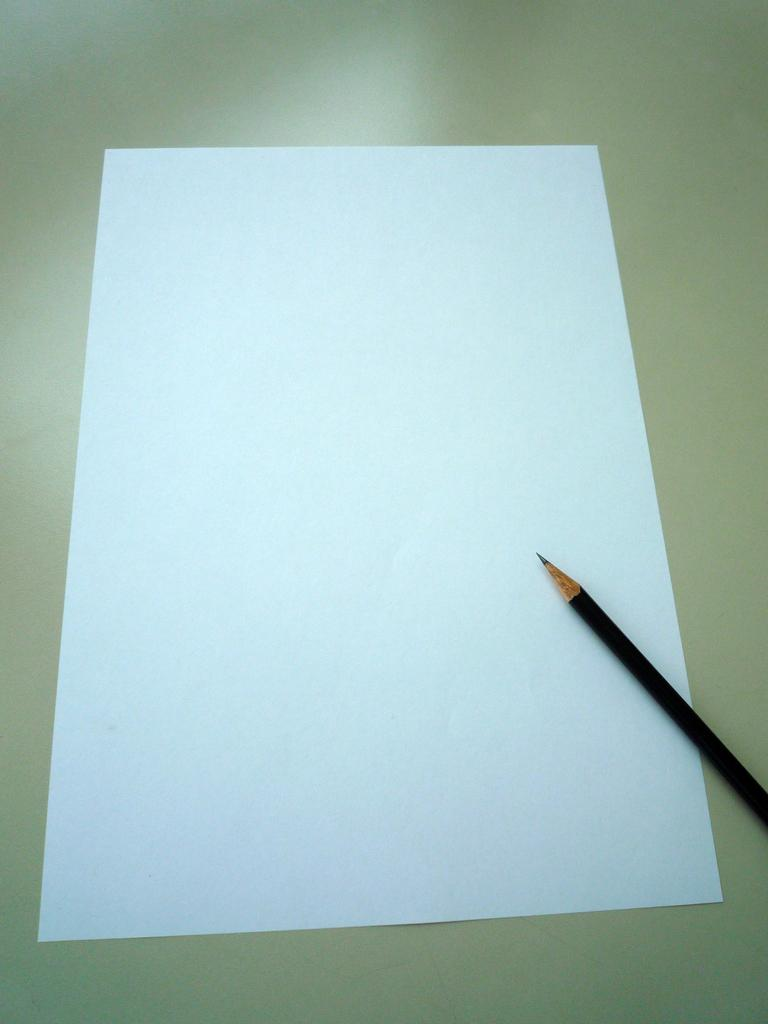What object can be seen in the image? There is a pencil in the image. What is the pencil placed on? The pencil is on a white paper. Where is the hose located in the image? There is no hose present in the image. What type of badge is visible on the pencil? There is no badge present on the pencil in the image. 